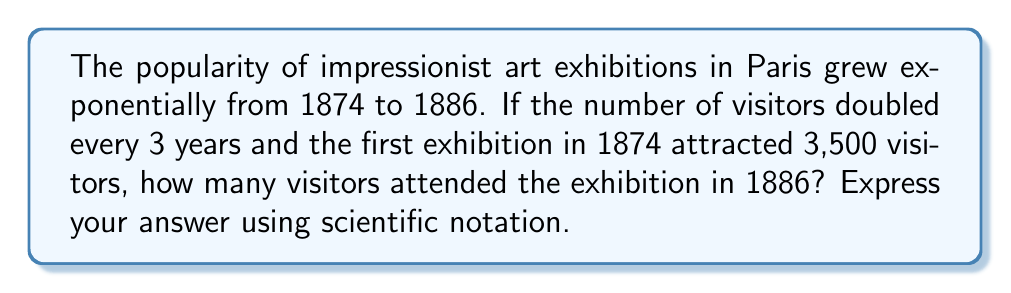Can you answer this question? Let's approach this step-by-step:

1) First, we need to determine how many 3-year periods passed between 1874 and 1886:
   1886 - 1874 = 12 years
   12 years ÷ 3 years = 4 periods

2) We're told that the number of visitors doubled every 3 years. This means we need to multiply the initial number by 2 four times:

   Initial visitors in 1874: 3,500
   After 3 years (1877): $3,500 \times 2 = 7,000$
   After 6 years (1880): $7,000 \times 2 = 14,000$
   After 9 years (1883): $14,000 \times 2 = 28,000$
   After 12 years (1886): $28,000 \times 2 = 56,000$

3) Alternatively, we can express this as an exponential function:
   $3,500 \times 2^4 = 3,500 \times 16 = 56,000$

4) To express this in scientific notation, we move the decimal point 4 places to the left:
   $56,000 = 5.6 \times 10^4$

This exponential growth mirrors the rapid rise in popularity of impressionist art during this period, reflecting the increasing appreciation for the movement's innovative techniques and subject matter.
Answer: $5.6 \times 10^4$ 